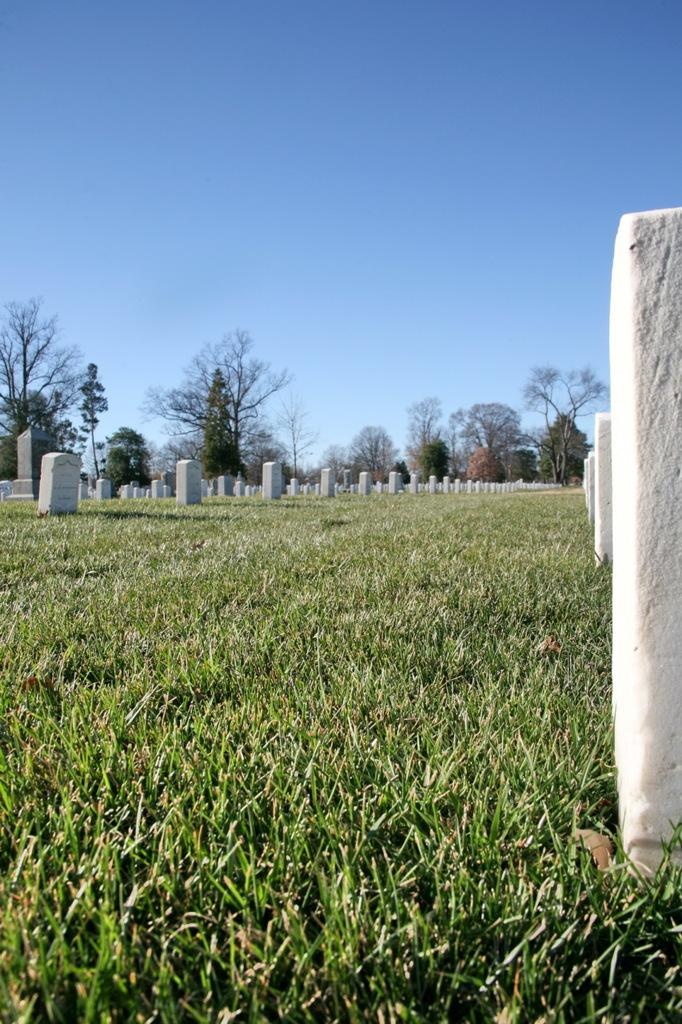What type of terrain is visible in the image? There is grassy land in the image. What is the main feature of the grassy land? There is a graveyard in the image. What can be seen in the background of the image? There are trees in the background of the image. What is visible at the top of the image? The sky is visible at the top of the image. How many cherries are hanging from the trees in the background? There are no cherries visible in the image; only trees are present. What type of glue is being used to hold the gravestones together? There is no indication of glue or any adhesive being used in the image; the gravestones are standing independently. 